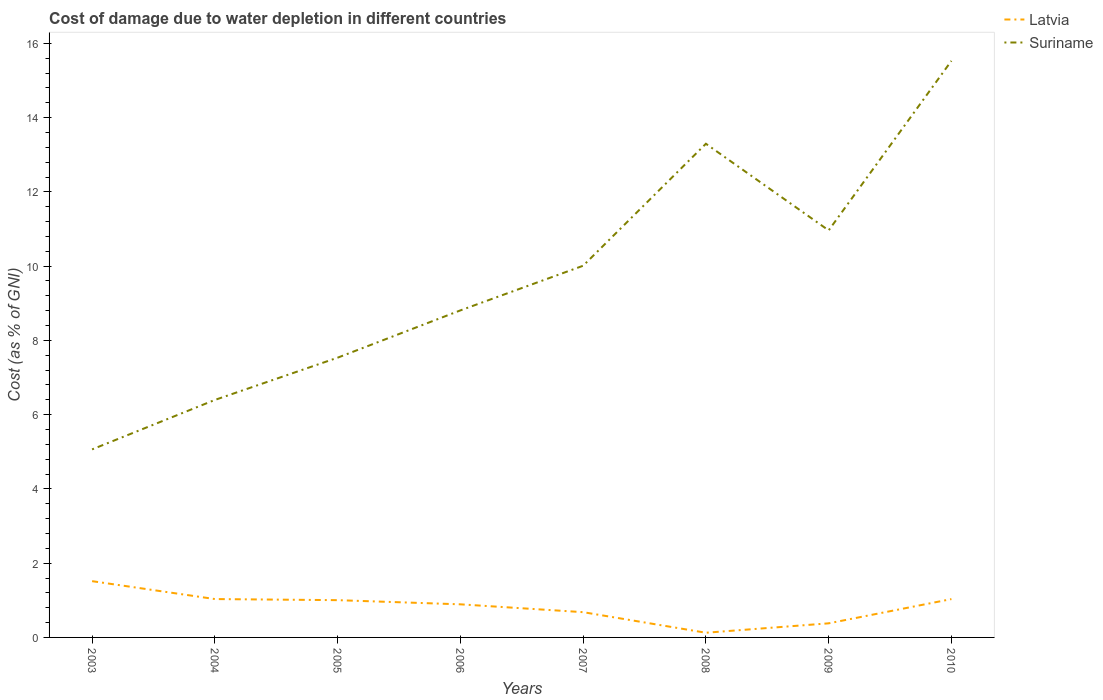Across all years, what is the maximum cost of damage caused due to water depletion in Latvia?
Provide a short and direct response. 0.13. What is the total cost of damage caused due to water depletion in Latvia in the graph?
Your answer should be compact. 0.51. What is the difference between the highest and the second highest cost of damage caused due to water depletion in Suriname?
Your answer should be compact. 10.46. What is the difference between the highest and the lowest cost of damage caused due to water depletion in Latvia?
Provide a short and direct response. 5. Is the cost of damage caused due to water depletion in Suriname strictly greater than the cost of damage caused due to water depletion in Latvia over the years?
Keep it short and to the point. No. How many years are there in the graph?
Offer a very short reply. 8. What is the difference between two consecutive major ticks on the Y-axis?
Keep it short and to the point. 2. How many legend labels are there?
Ensure brevity in your answer.  2. What is the title of the graph?
Your answer should be compact. Cost of damage due to water depletion in different countries. What is the label or title of the Y-axis?
Offer a terse response. Cost (as % of GNI). What is the Cost (as % of GNI) of Latvia in 2003?
Give a very brief answer. 1.52. What is the Cost (as % of GNI) of Suriname in 2003?
Your answer should be very brief. 5.06. What is the Cost (as % of GNI) of Latvia in 2004?
Keep it short and to the point. 1.03. What is the Cost (as % of GNI) in Suriname in 2004?
Give a very brief answer. 6.4. What is the Cost (as % of GNI) of Latvia in 2005?
Your response must be concise. 1. What is the Cost (as % of GNI) in Suriname in 2005?
Offer a terse response. 7.53. What is the Cost (as % of GNI) in Latvia in 2006?
Keep it short and to the point. 0.89. What is the Cost (as % of GNI) of Suriname in 2006?
Give a very brief answer. 8.81. What is the Cost (as % of GNI) in Latvia in 2007?
Your response must be concise. 0.68. What is the Cost (as % of GNI) in Suriname in 2007?
Provide a short and direct response. 10.01. What is the Cost (as % of GNI) in Latvia in 2008?
Make the answer very short. 0.13. What is the Cost (as % of GNI) of Suriname in 2008?
Give a very brief answer. 13.3. What is the Cost (as % of GNI) in Latvia in 2009?
Provide a succinct answer. 0.38. What is the Cost (as % of GNI) in Suriname in 2009?
Your response must be concise. 10.96. What is the Cost (as % of GNI) in Latvia in 2010?
Your answer should be compact. 1.03. What is the Cost (as % of GNI) of Suriname in 2010?
Provide a succinct answer. 15.53. Across all years, what is the maximum Cost (as % of GNI) of Latvia?
Your answer should be very brief. 1.52. Across all years, what is the maximum Cost (as % of GNI) in Suriname?
Provide a short and direct response. 15.53. Across all years, what is the minimum Cost (as % of GNI) in Latvia?
Ensure brevity in your answer.  0.13. Across all years, what is the minimum Cost (as % of GNI) in Suriname?
Provide a short and direct response. 5.06. What is the total Cost (as % of GNI) of Latvia in the graph?
Offer a terse response. 6.66. What is the total Cost (as % of GNI) in Suriname in the graph?
Offer a very short reply. 77.6. What is the difference between the Cost (as % of GNI) of Latvia in 2003 and that in 2004?
Give a very brief answer. 0.48. What is the difference between the Cost (as % of GNI) of Suriname in 2003 and that in 2004?
Offer a terse response. -1.33. What is the difference between the Cost (as % of GNI) of Latvia in 2003 and that in 2005?
Provide a short and direct response. 0.51. What is the difference between the Cost (as % of GNI) in Suriname in 2003 and that in 2005?
Your answer should be compact. -2.47. What is the difference between the Cost (as % of GNI) in Latvia in 2003 and that in 2006?
Offer a terse response. 0.62. What is the difference between the Cost (as % of GNI) of Suriname in 2003 and that in 2006?
Offer a terse response. -3.74. What is the difference between the Cost (as % of GNI) in Latvia in 2003 and that in 2007?
Keep it short and to the point. 0.84. What is the difference between the Cost (as % of GNI) of Suriname in 2003 and that in 2007?
Make the answer very short. -4.95. What is the difference between the Cost (as % of GNI) of Latvia in 2003 and that in 2008?
Provide a short and direct response. 1.39. What is the difference between the Cost (as % of GNI) of Suriname in 2003 and that in 2008?
Make the answer very short. -8.23. What is the difference between the Cost (as % of GNI) in Latvia in 2003 and that in 2009?
Give a very brief answer. 1.14. What is the difference between the Cost (as % of GNI) of Suriname in 2003 and that in 2009?
Give a very brief answer. -5.9. What is the difference between the Cost (as % of GNI) of Latvia in 2003 and that in 2010?
Provide a short and direct response. 0.48. What is the difference between the Cost (as % of GNI) of Suriname in 2003 and that in 2010?
Offer a terse response. -10.46. What is the difference between the Cost (as % of GNI) of Latvia in 2004 and that in 2005?
Ensure brevity in your answer.  0.03. What is the difference between the Cost (as % of GNI) in Suriname in 2004 and that in 2005?
Your answer should be very brief. -1.14. What is the difference between the Cost (as % of GNI) of Latvia in 2004 and that in 2006?
Provide a short and direct response. 0.14. What is the difference between the Cost (as % of GNI) in Suriname in 2004 and that in 2006?
Give a very brief answer. -2.41. What is the difference between the Cost (as % of GNI) in Latvia in 2004 and that in 2007?
Keep it short and to the point. 0.35. What is the difference between the Cost (as % of GNI) of Suriname in 2004 and that in 2007?
Provide a short and direct response. -3.61. What is the difference between the Cost (as % of GNI) in Latvia in 2004 and that in 2008?
Provide a short and direct response. 0.91. What is the difference between the Cost (as % of GNI) in Suriname in 2004 and that in 2008?
Provide a short and direct response. -6.9. What is the difference between the Cost (as % of GNI) in Latvia in 2004 and that in 2009?
Your answer should be compact. 0.65. What is the difference between the Cost (as % of GNI) of Suriname in 2004 and that in 2009?
Offer a very short reply. -4.57. What is the difference between the Cost (as % of GNI) in Latvia in 2004 and that in 2010?
Offer a very short reply. 0. What is the difference between the Cost (as % of GNI) of Suriname in 2004 and that in 2010?
Ensure brevity in your answer.  -9.13. What is the difference between the Cost (as % of GNI) of Latvia in 2005 and that in 2006?
Keep it short and to the point. 0.11. What is the difference between the Cost (as % of GNI) in Suriname in 2005 and that in 2006?
Keep it short and to the point. -1.27. What is the difference between the Cost (as % of GNI) in Latvia in 2005 and that in 2007?
Ensure brevity in your answer.  0.32. What is the difference between the Cost (as % of GNI) in Suriname in 2005 and that in 2007?
Make the answer very short. -2.48. What is the difference between the Cost (as % of GNI) of Latvia in 2005 and that in 2008?
Your answer should be very brief. 0.88. What is the difference between the Cost (as % of GNI) in Suriname in 2005 and that in 2008?
Keep it short and to the point. -5.76. What is the difference between the Cost (as % of GNI) in Latvia in 2005 and that in 2009?
Provide a succinct answer. 0.62. What is the difference between the Cost (as % of GNI) in Suriname in 2005 and that in 2009?
Ensure brevity in your answer.  -3.43. What is the difference between the Cost (as % of GNI) in Latvia in 2005 and that in 2010?
Provide a short and direct response. -0.03. What is the difference between the Cost (as % of GNI) in Suriname in 2005 and that in 2010?
Your answer should be compact. -7.99. What is the difference between the Cost (as % of GNI) of Latvia in 2006 and that in 2007?
Offer a terse response. 0.21. What is the difference between the Cost (as % of GNI) in Suriname in 2006 and that in 2007?
Your response must be concise. -1.2. What is the difference between the Cost (as % of GNI) in Latvia in 2006 and that in 2008?
Offer a terse response. 0.77. What is the difference between the Cost (as % of GNI) of Suriname in 2006 and that in 2008?
Offer a very short reply. -4.49. What is the difference between the Cost (as % of GNI) of Latvia in 2006 and that in 2009?
Your answer should be very brief. 0.51. What is the difference between the Cost (as % of GNI) of Suriname in 2006 and that in 2009?
Offer a terse response. -2.15. What is the difference between the Cost (as % of GNI) in Latvia in 2006 and that in 2010?
Provide a succinct answer. -0.14. What is the difference between the Cost (as % of GNI) of Suriname in 2006 and that in 2010?
Offer a terse response. -6.72. What is the difference between the Cost (as % of GNI) of Latvia in 2007 and that in 2008?
Your answer should be very brief. 0.55. What is the difference between the Cost (as % of GNI) in Suriname in 2007 and that in 2008?
Your answer should be very brief. -3.29. What is the difference between the Cost (as % of GNI) of Latvia in 2007 and that in 2009?
Ensure brevity in your answer.  0.3. What is the difference between the Cost (as % of GNI) in Suriname in 2007 and that in 2009?
Your answer should be very brief. -0.95. What is the difference between the Cost (as % of GNI) in Latvia in 2007 and that in 2010?
Offer a terse response. -0.35. What is the difference between the Cost (as % of GNI) of Suriname in 2007 and that in 2010?
Ensure brevity in your answer.  -5.52. What is the difference between the Cost (as % of GNI) in Latvia in 2008 and that in 2009?
Provide a succinct answer. -0.25. What is the difference between the Cost (as % of GNI) of Suriname in 2008 and that in 2009?
Offer a terse response. 2.33. What is the difference between the Cost (as % of GNI) of Latvia in 2008 and that in 2010?
Your response must be concise. -0.91. What is the difference between the Cost (as % of GNI) of Suriname in 2008 and that in 2010?
Your response must be concise. -2.23. What is the difference between the Cost (as % of GNI) in Latvia in 2009 and that in 2010?
Ensure brevity in your answer.  -0.65. What is the difference between the Cost (as % of GNI) of Suriname in 2009 and that in 2010?
Provide a short and direct response. -4.57. What is the difference between the Cost (as % of GNI) in Latvia in 2003 and the Cost (as % of GNI) in Suriname in 2004?
Your answer should be very brief. -4.88. What is the difference between the Cost (as % of GNI) of Latvia in 2003 and the Cost (as % of GNI) of Suriname in 2005?
Your answer should be very brief. -6.02. What is the difference between the Cost (as % of GNI) in Latvia in 2003 and the Cost (as % of GNI) in Suriname in 2006?
Your answer should be compact. -7.29. What is the difference between the Cost (as % of GNI) in Latvia in 2003 and the Cost (as % of GNI) in Suriname in 2007?
Make the answer very short. -8.5. What is the difference between the Cost (as % of GNI) of Latvia in 2003 and the Cost (as % of GNI) of Suriname in 2008?
Give a very brief answer. -11.78. What is the difference between the Cost (as % of GNI) of Latvia in 2003 and the Cost (as % of GNI) of Suriname in 2009?
Your answer should be compact. -9.45. What is the difference between the Cost (as % of GNI) in Latvia in 2003 and the Cost (as % of GNI) in Suriname in 2010?
Provide a succinct answer. -14.01. What is the difference between the Cost (as % of GNI) in Latvia in 2004 and the Cost (as % of GNI) in Suriname in 2005?
Give a very brief answer. -6.5. What is the difference between the Cost (as % of GNI) in Latvia in 2004 and the Cost (as % of GNI) in Suriname in 2006?
Provide a short and direct response. -7.77. What is the difference between the Cost (as % of GNI) of Latvia in 2004 and the Cost (as % of GNI) of Suriname in 2007?
Ensure brevity in your answer.  -8.98. What is the difference between the Cost (as % of GNI) in Latvia in 2004 and the Cost (as % of GNI) in Suriname in 2008?
Provide a short and direct response. -12.26. What is the difference between the Cost (as % of GNI) in Latvia in 2004 and the Cost (as % of GNI) in Suriname in 2009?
Offer a very short reply. -9.93. What is the difference between the Cost (as % of GNI) in Latvia in 2004 and the Cost (as % of GNI) in Suriname in 2010?
Your answer should be compact. -14.5. What is the difference between the Cost (as % of GNI) in Latvia in 2005 and the Cost (as % of GNI) in Suriname in 2006?
Your answer should be very brief. -7.8. What is the difference between the Cost (as % of GNI) of Latvia in 2005 and the Cost (as % of GNI) of Suriname in 2007?
Ensure brevity in your answer.  -9.01. What is the difference between the Cost (as % of GNI) of Latvia in 2005 and the Cost (as % of GNI) of Suriname in 2008?
Keep it short and to the point. -12.29. What is the difference between the Cost (as % of GNI) of Latvia in 2005 and the Cost (as % of GNI) of Suriname in 2009?
Provide a short and direct response. -9.96. What is the difference between the Cost (as % of GNI) in Latvia in 2005 and the Cost (as % of GNI) in Suriname in 2010?
Ensure brevity in your answer.  -14.53. What is the difference between the Cost (as % of GNI) in Latvia in 2006 and the Cost (as % of GNI) in Suriname in 2007?
Your answer should be very brief. -9.12. What is the difference between the Cost (as % of GNI) in Latvia in 2006 and the Cost (as % of GNI) in Suriname in 2008?
Your answer should be compact. -12.4. What is the difference between the Cost (as % of GNI) in Latvia in 2006 and the Cost (as % of GNI) in Suriname in 2009?
Give a very brief answer. -10.07. What is the difference between the Cost (as % of GNI) of Latvia in 2006 and the Cost (as % of GNI) of Suriname in 2010?
Your answer should be compact. -14.64. What is the difference between the Cost (as % of GNI) in Latvia in 2007 and the Cost (as % of GNI) in Suriname in 2008?
Your answer should be very brief. -12.62. What is the difference between the Cost (as % of GNI) in Latvia in 2007 and the Cost (as % of GNI) in Suriname in 2009?
Keep it short and to the point. -10.28. What is the difference between the Cost (as % of GNI) in Latvia in 2007 and the Cost (as % of GNI) in Suriname in 2010?
Ensure brevity in your answer.  -14.85. What is the difference between the Cost (as % of GNI) of Latvia in 2008 and the Cost (as % of GNI) of Suriname in 2009?
Provide a succinct answer. -10.84. What is the difference between the Cost (as % of GNI) of Latvia in 2008 and the Cost (as % of GNI) of Suriname in 2010?
Ensure brevity in your answer.  -15.4. What is the difference between the Cost (as % of GNI) of Latvia in 2009 and the Cost (as % of GNI) of Suriname in 2010?
Your response must be concise. -15.15. What is the average Cost (as % of GNI) of Latvia per year?
Keep it short and to the point. 0.83. What is the average Cost (as % of GNI) of Suriname per year?
Offer a terse response. 9.7. In the year 2003, what is the difference between the Cost (as % of GNI) of Latvia and Cost (as % of GNI) of Suriname?
Offer a terse response. -3.55. In the year 2004, what is the difference between the Cost (as % of GNI) of Latvia and Cost (as % of GNI) of Suriname?
Your answer should be very brief. -5.36. In the year 2005, what is the difference between the Cost (as % of GNI) of Latvia and Cost (as % of GNI) of Suriname?
Keep it short and to the point. -6.53. In the year 2006, what is the difference between the Cost (as % of GNI) of Latvia and Cost (as % of GNI) of Suriname?
Your answer should be very brief. -7.92. In the year 2007, what is the difference between the Cost (as % of GNI) in Latvia and Cost (as % of GNI) in Suriname?
Your response must be concise. -9.33. In the year 2008, what is the difference between the Cost (as % of GNI) in Latvia and Cost (as % of GNI) in Suriname?
Make the answer very short. -13.17. In the year 2009, what is the difference between the Cost (as % of GNI) in Latvia and Cost (as % of GNI) in Suriname?
Your answer should be compact. -10.58. In the year 2010, what is the difference between the Cost (as % of GNI) of Latvia and Cost (as % of GNI) of Suriname?
Make the answer very short. -14.5. What is the ratio of the Cost (as % of GNI) of Latvia in 2003 to that in 2004?
Give a very brief answer. 1.47. What is the ratio of the Cost (as % of GNI) of Suriname in 2003 to that in 2004?
Your answer should be very brief. 0.79. What is the ratio of the Cost (as % of GNI) of Latvia in 2003 to that in 2005?
Your answer should be compact. 1.51. What is the ratio of the Cost (as % of GNI) of Suriname in 2003 to that in 2005?
Keep it short and to the point. 0.67. What is the ratio of the Cost (as % of GNI) of Latvia in 2003 to that in 2006?
Keep it short and to the point. 1.7. What is the ratio of the Cost (as % of GNI) of Suriname in 2003 to that in 2006?
Your answer should be compact. 0.57. What is the ratio of the Cost (as % of GNI) of Latvia in 2003 to that in 2007?
Your answer should be very brief. 2.23. What is the ratio of the Cost (as % of GNI) in Suriname in 2003 to that in 2007?
Your response must be concise. 0.51. What is the ratio of the Cost (as % of GNI) in Latvia in 2003 to that in 2008?
Make the answer very short. 12.01. What is the ratio of the Cost (as % of GNI) of Suriname in 2003 to that in 2008?
Offer a very short reply. 0.38. What is the ratio of the Cost (as % of GNI) of Latvia in 2003 to that in 2009?
Ensure brevity in your answer.  3.99. What is the ratio of the Cost (as % of GNI) of Suriname in 2003 to that in 2009?
Make the answer very short. 0.46. What is the ratio of the Cost (as % of GNI) in Latvia in 2003 to that in 2010?
Keep it short and to the point. 1.47. What is the ratio of the Cost (as % of GNI) in Suriname in 2003 to that in 2010?
Your answer should be very brief. 0.33. What is the ratio of the Cost (as % of GNI) in Latvia in 2004 to that in 2005?
Provide a short and direct response. 1.03. What is the ratio of the Cost (as % of GNI) in Suriname in 2004 to that in 2005?
Your answer should be compact. 0.85. What is the ratio of the Cost (as % of GNI) of Latvia in 2004 to that in 2006?
Provide a succinct answer. 1.16. What is the ratio of the Cost (as % of GNI) of Suriname in 2004 to that in 2006?
Ensure brevity in your answer.  0.73. What is the ratio of the Cost (as % of GNI) of Latvia in 2004 to that in 2007?
Offer a very short reply. 1.52. What is the ratio of the Cost (as % of GNI) of Suriname in 2004 to that in 2007?
Keep it short and to the point. 0.64. What is the ratio of the Cost (as % of GNI) in Latvia in 2004 to that in 2008?
Keep it short and to the point. 8.19. What is the ratio of the Cost (as % of GNI) in Suriname in 2004 to that in 2008?
Ensure brevity in your answer.  0.48. What is the ratio of the Cost (as % of GNI) in Latvia in 2004 to that in 2009?
Your answer should be very brief. 2.72. What is the ratio of the Cost (as % of GNI) in Suriname in 2004 to that in 2009?
Ensure brevity in your answer.  0.58. What is the ratio of the Cost (as % of GNI) in Latvia in 2004 to that in 2010?
Provide a succinct answer. 1. What is the ratio of the Cost (as % of GNI) in Suriname in 2004 to that in 2010?
Your answer should be very brief. 0.41. What is the ratio of the Cost (as % of GNI) in Latvia in 2005 to that in 2006?
Provide a succinct answer. 1.13. What is the ratio of the Cost (as % of GNI) in Suriname in 2005 to that in 2006?
Your answer should be very brief. 0.86. What is the ratio of the Cost (as % of GNI) in Latvia in 2005 to that in 2007?
Offer a very short reply. 1.48. What is the ratio of the Cost (as % of GNI) of Suriname in 2005 to that in 2007?
Give a very brief answer. 0.75. What is the ratio of the Cost (as % of GNI) in Latvia in 2005 to that in 2008?
Ensure brevity in your answer.  7.95. What is the ratio of the Cost (as % of GNI) in Suriname in 2005 to that in 2008?
Offer a terse response. 0.57. What is the ratio of the Cost (as % of GNI) in Latvia in 2005 to that in 2009?
Give a very brief answer. 2.64. What is the ratio of the Cost (as % of GNI) of Suriname in 2005 to that in 2009?
Your response must be concise. 0.69. What is the ratio of the Cost (as % of GNI) of Latvia in 2005 to that in 2010?
Provide a succinct answer. 0.97. What is the ratio of the Cost (as % of GNI) of Suriname in 2005 to that in 2010?
Offer a very short reply. 0.49. What is the ratio of the Cost (as % of GNI) in Latvia in 2006 to that in 2007?
Provide a short and direct response. 1.31. What is the ratio of the Cost (as % of GNI) of Suriname in 2006 to that in 2007?
Your answer should be very brief. 0.88. What is the ratio of the Cost (as % of GNI) in Latvia in 2006 to that in 2008?
Ensure brevity in your answer.  7.06. What is the ratio of the Cost (as % of GNI) of Suriname in 2006 to that in 2008?
Your response must be concise. 0.66. What is the ratio of the Cost (as % of GNI) in Latvia in 2006 to that in 2009?
Make the answer very short. 2.35. What is the ratio of the Cost (as % of GNI) in Suriname in 2006 to that in 2009?
Ensure brevity in your answer.  0.8. What is the ratio of the Cost (as % of GNI) of Latvia in 2006 to that in 2010?
Make the answer very short. 0.86. What is the ratio of the Cost (as % of GNI) in Suriname in 2006 to that in 2010?
Provide a succinct answer. 0.57. What is the ratio of the Cost (as % of GNI) of Latvia in 2007 to that in 2008?
Provide a short and direct response. 5.39. What is the ratio of the Cost (as % of GNI) in Suriname in 2007 to that in 2008?
Your answer should be compact. 0.75. What is the ratio of the Cost (as % of GNI) in Latvia in 2007 to that in 2009?
Offer a terse response. 1.79. What is the ratio of the Cost (as % of GNI) in Suriname in 2007 to that in 2009?
Keep it short and to the point. 0.91. What is the ratio of the Cost (as % of GNI) in Latvia in 2007 to that in 2010?
Keep it short and to the point. 0.66. What is the ratio of the Cost (as % of GNI) in Suriname in 2007 to that in 2010?
Your answer should be compact. 0.64. What is the ratio of the Cost (as % of GNI) in Latvia in 2008 to that in 2009?
Your response must be concise. 0.33. What is the ratio of the Cost (as % of GNI) in Suriname in 2008 to that in 2009?
Offer a terse response. 1.21. What is the ratio of the Cost (as % of GNI) in Latvia in 2008 to that in 2010?
Your answer should be compact. 0.12. What is the ratio of the Cost (as % of GNI) in Suriname in 2008 to that in 2010?
Provide a short and direct response. 0.86. What is the ratio of the Cost (as % of GNI) of Latvia in 2009 to that in 2010?
Your answer should be very brief. 0.37. What is the ratio of the Cost (as % of GNI) of Suriname in 2009 to that in 2010?
Your answer should be very brief. 0.71. What is the difference between the highest and the second highest Cost (as % of GNI) of Latvia?
Offer a terse response. 0.48. What is the difference between the highest and the second highest Cost (as % of GNI) in Suriname?
Give a very brief answer. 2.23. What is the difference between the highest and the lowest Cost (as % of GNI) of Latvia?
Your answer should be very brief. 1.39. What is the difference between the highest and the lowest Cost (as % of GNI) of Suriname?
Make the answer very short. 10.46. 